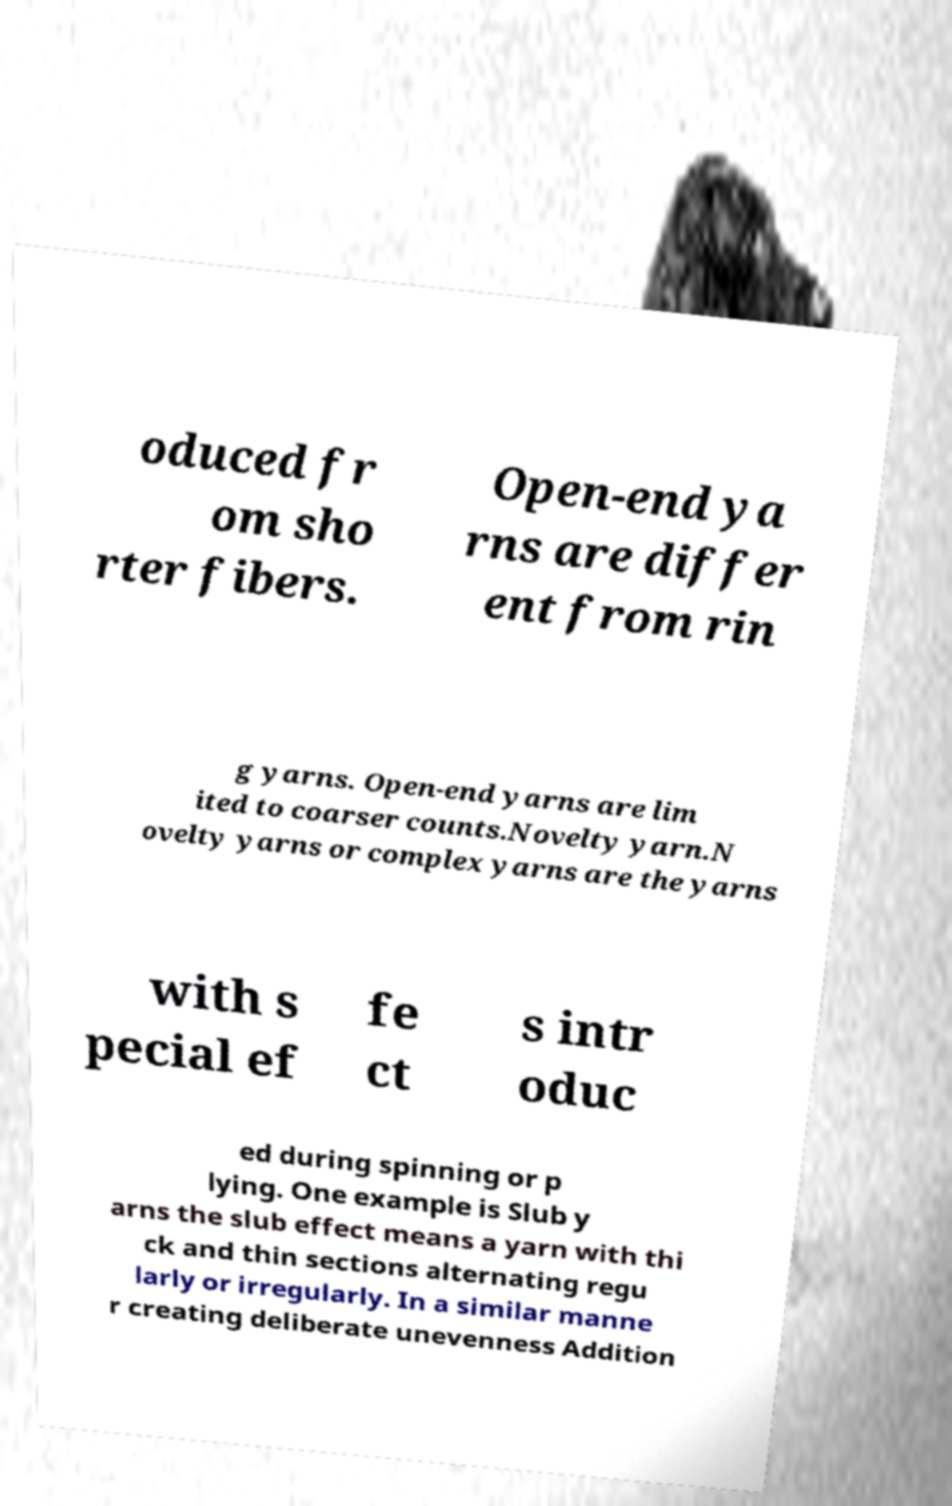Please read and relay the text visible in this image. What does it say? oduced fr om sho rter fibers. Open-end ya rns are differ ent from rin g yarns. Open-end yarns are lim ited to coarser counts.Novelty yarn.N ovelty yarns or complex yarns are the yarns with s pecial ef fe ct s intr oduc ed during spinning or p lying. One example is Slub y arns the slub effect means a yarn with thi ck and thin sections alternating regu larly or irregularly. In a similar manne r creating deliberate unevenness Addition 